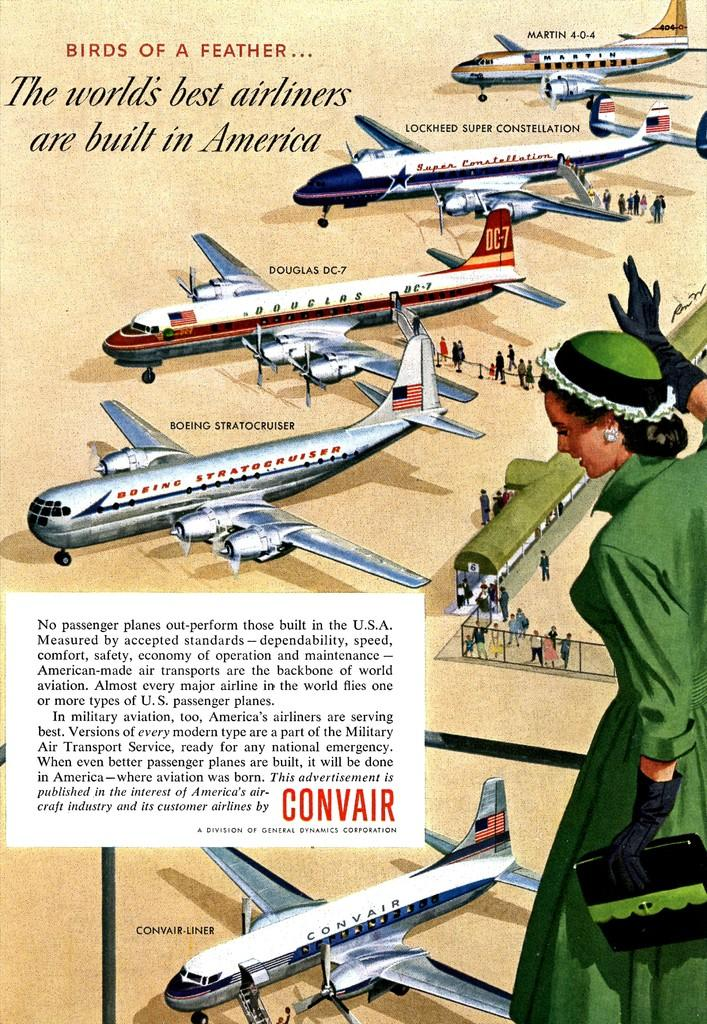<image>
Summarize the visual content of the image. A vintage ad of airplanes with the tagline "The world's best airliners are built in America" 